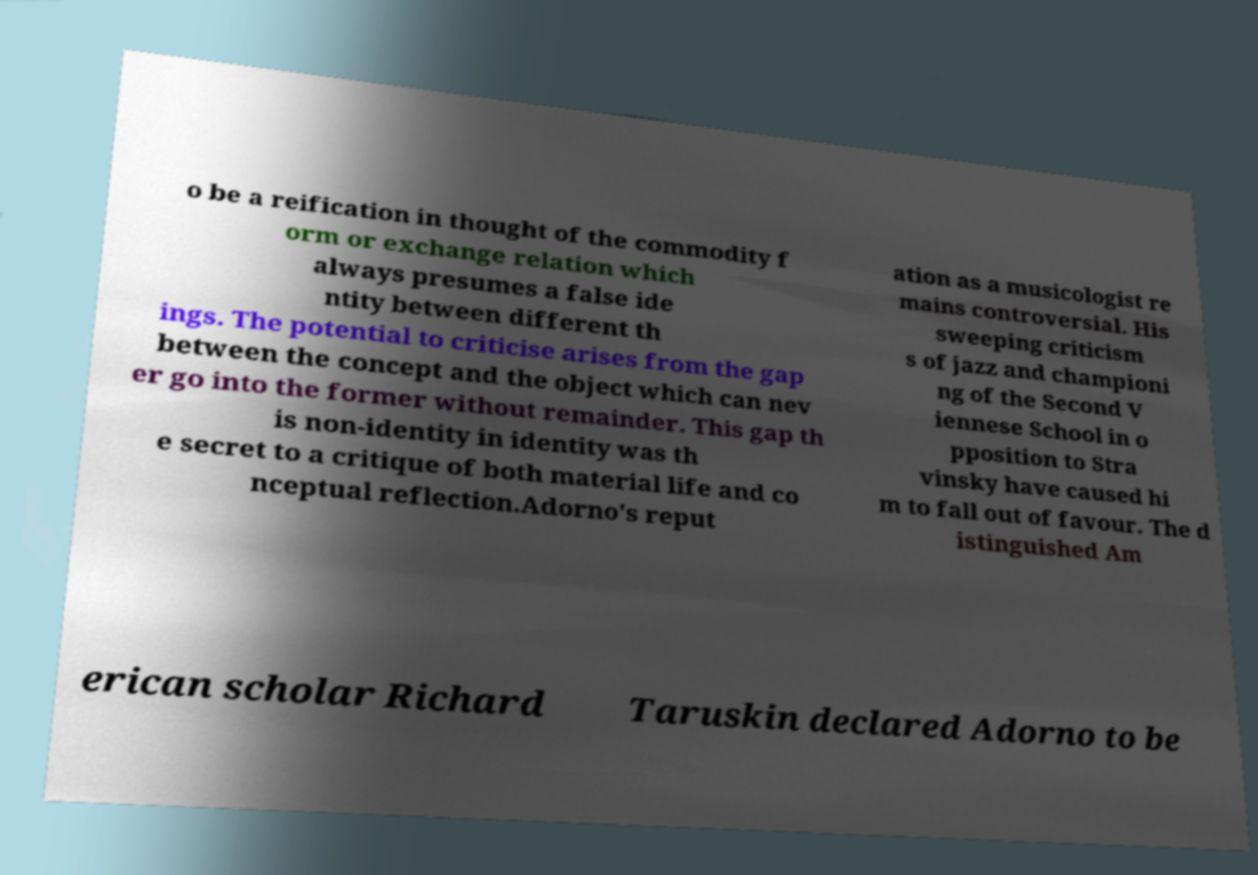Please identify and transcribe the text found in this image. o be a reification in thought of the commodity f orm or exchange relation which always presumes a false ide ntity between different th ings. The potential to criticise arises from the gap between the concept and the object which can nev er go into the former without remainder. This gap th is non-identity in identity was th e secret to a critique of both material life and co nceptual reflection.Adorno's reput ation as a musicologist re mains controversial. His sweeping criticism s of jazz and championi ng of the Second V iennese School in o pposition to Stra vinsky have caused hi m to fall out of favour. The d istinguished Am erican scholar Richard Taruskin declared Adorno to be 